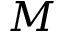Convert formula to latex. <formula><loc_0><loc_0><loc_500><loc_500>M</formula> 